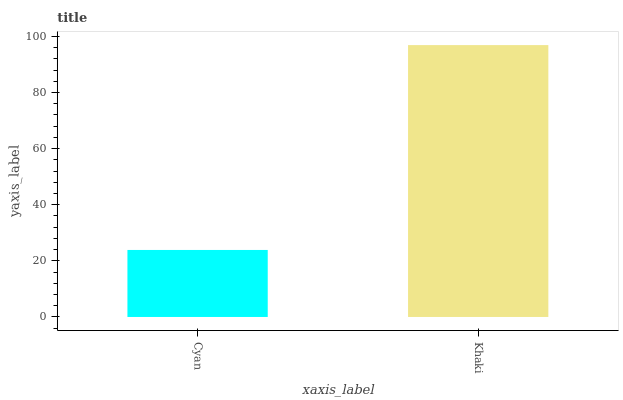Is Cyan the minimum?
Answer yes or no. Yes. Is Khaki the maximum?
Answer yes or no. Yes. Is Khaki the minimum?
Answer yes or no. No. Is Khaki greater than Cyan?
Answer yes or no. Yes. Is Cyan less than Khaki?
Answer yes or no. Yes. Is Cyan greater than Khaki?
Answer yes or no. No. Is Khaki less than Cyan?
Answer yes or no. No. Is Khaki the high median?
Answer yes or no. Yes. Is Cyan the low median?
Answer yes or no. Yes. Is Cyan the high median?
Answer yes or no. No. Is Khaki the low median?
Answer yes or no. No. 